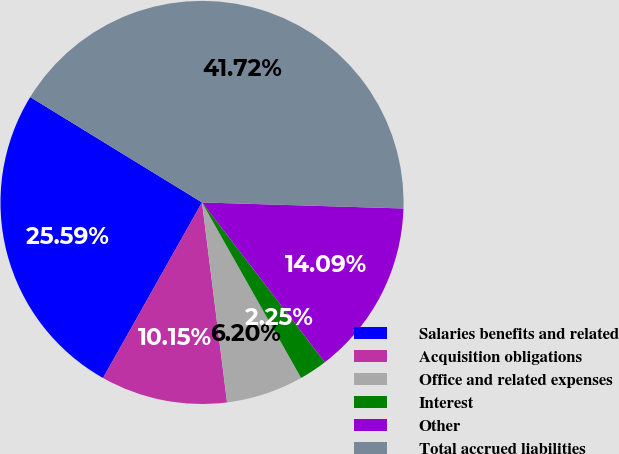Convert chart to OTSL. <chart><loc_0><loc_0><loc_500><loc_500><pie_chart><fcel>Salaries benefits and related<fcel>Acquisition obligations<fcel>Office and related expenses<fcel>Interest<fcel>Other<fcel>Total accrued liabilities<nl><fcel>25.59%<fcel>10.15%<fcel>6.2%<fcel>2.25%<fcel>14.09%<fcel>41.72%<nl></chart> 